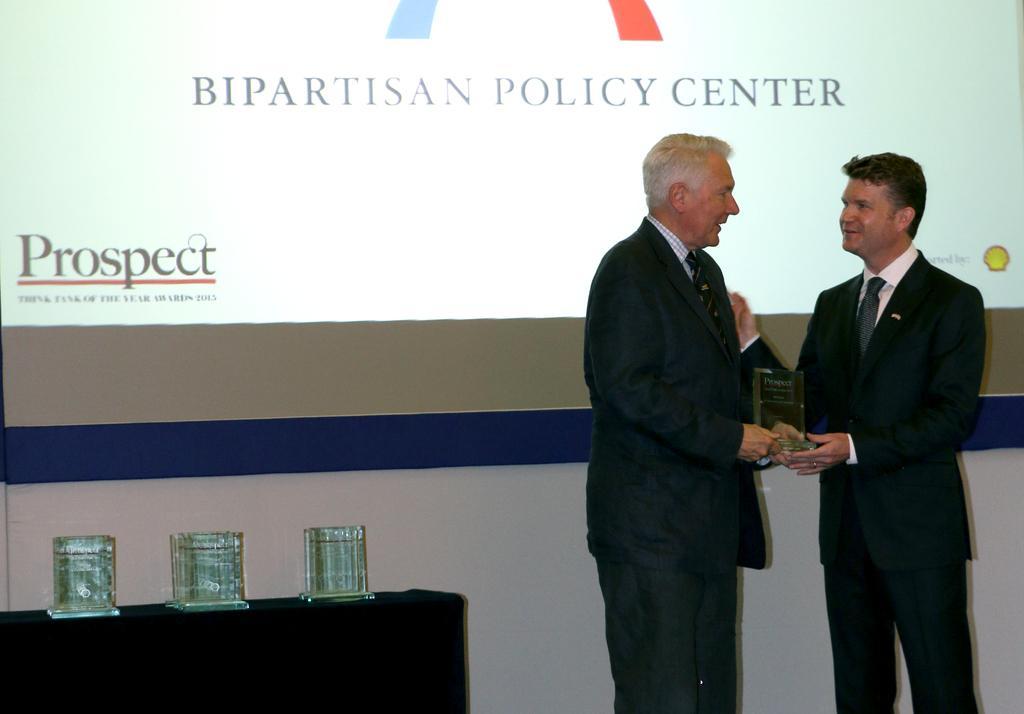Could you give a brief overview of what you see in this image? In this picture there are two men who are holding the prize. They are standing near to the projector screen. In the bottom left corner I can see some prize which are kept on the table. 